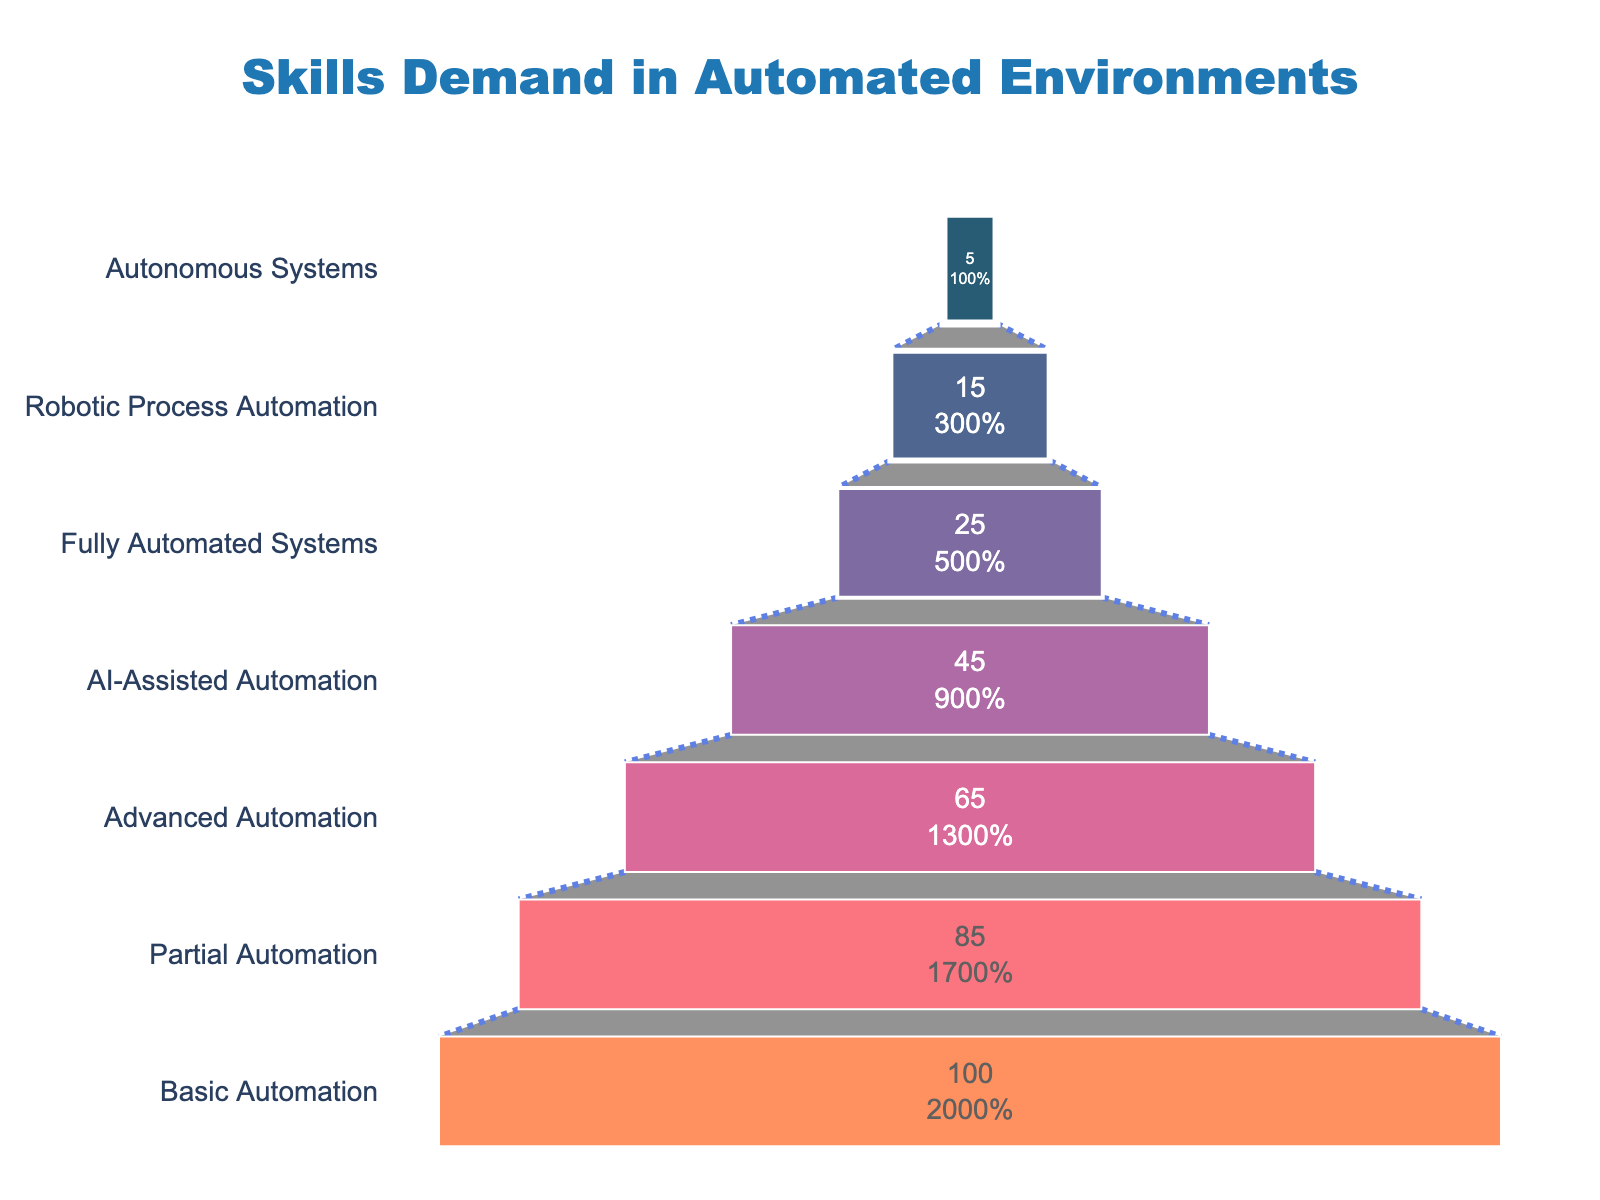What is the title of the funnel chart? The title is displayed at the top center of the funnel chart.
Answer: Skills Demand in Automated Environments How many stages are shown in the funnel chart? Counting the different stages listed along the funnel chart reveals the total number.
Answer: Seven Which stage has the highest skill demand? By observing the length of the bars in the funnel chart, we see the widest bar corresponds to the highest skill demand.
Answer: Basic Automation How much skill demand percentage decreases from Advanced Automation to AI-Assisted Automation? Subtract the skill demand of AI-Assisted Automation from that of Advanced Automation (65% - 45%).
Answer: 20% Which stages have skill demands below 50%? By identifying the stages with bars smaller than the 50% mark, we find AI-Assisted Automation, Fully Automated Systems, Robotic Process Automation, and Autonomous Systems.
Answer: AI-Assisted Automation, Fully Automated Systems, Robotic Process Automation, Autonomous Systems Compare the skill demand between Partial Automation and Robotic Process Automation. By comparing the lengths of the bars for these stages, we find that Partial Automation has a higher skill demand than Robotic Process Automation.
Answer: Partial Automation > Robotic Process Automation What percentage of skill demand does Fully Automated Systems stage represent out of the total given percentages? Sum all the percentages and find what fraction Fully Automated Systems represents. Total = 340%; 25% of 340% = 25/340 ≈ 7.4%
Answer: About 7.4% Which color represents the Autonomous Systems stage in the funnel chart? By looking at the color-coded bars, the last stage, Autonomous Systems, is represented by the color orange.
Answer: Orange Which stage has the closest skill demand percentage to the median value of all stages? List the percentages in ascending order (5, 15, 25, 45, 65, 85, 100) and find the median value, which is 45%, corresponding to the AI-Assisted Automation stage.
Answer: AI-Assisted Automation By how much does the skill demand decrease between Basic Automation and Advanced Automation? Subtract the skill demand of Advanced Automation from Basic Automation (100% - 65%).
Answer: 35% 